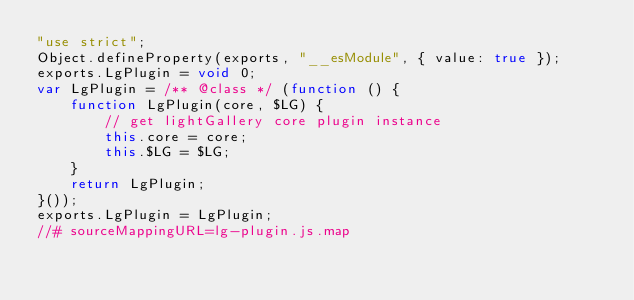<code> <loc_0><loc_0><loc_500><loc_500><_JavaScript_>"use strict";
Object.defineProperty(exports, "__esModule", { value: true });
exports.LgPlugin = void 0;
var LgPlugin = /** @class */ (function () {
    function LgPlugin(core, $LG) {
        // get lightGallery core plugin instance
        this.core = core;
        this.$LG = $LG;
    }
    return LgPlugin;
}());
exports.LgPlugin = LgPlugin;
//# sourceMappingURL=lg-plugin.js.map</code> 